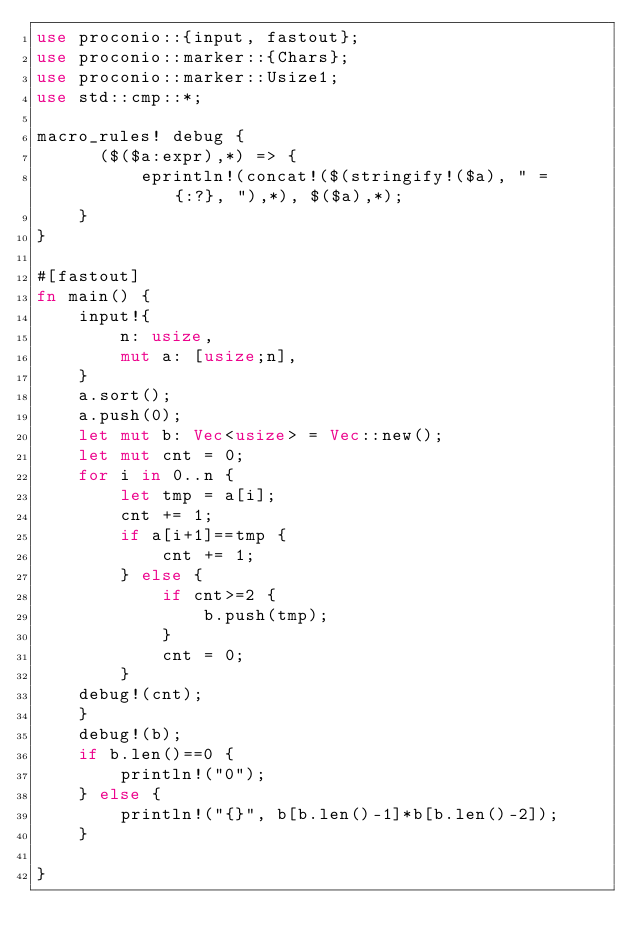<code> <loc_0><loc_0><loc_500><loc_500><_Rust_>use proconio::{input, fastout};
use proconio::marker::{Chars};
use proconio::marker::Usize1;
use std::cmp::*;

macro_rules! debug {
      ($($a:expr),*) => {
          eprintln!(concat!($(stringify!($a), " = {:?}, "),*), $($a),*);
    }
}

#[fastout]
fn main() {
    input!{
        n: usize,
        mut a: [usize;n],
    }
    a.sort();
    a.push(0);
    let mut b: Vec<usize> = Vec::new();
    let mut cnt = 0;
    for i in 0..n {
        let tmp = a[i];
        cnt += 1;
        if a[i+1]==tmp {
            cnt += 1;
        } else {
            if cnt>=2 {
                b.push(tmp);
            }
            cnt = 0;
        }
    debug!(cnt);
    }
    debug!(b);
    if b.len()==0 {
        println!("0");
    } else {
        println!("{}", b[b.len()-1]*b[b.len()-2]);
    }

}
</code> 